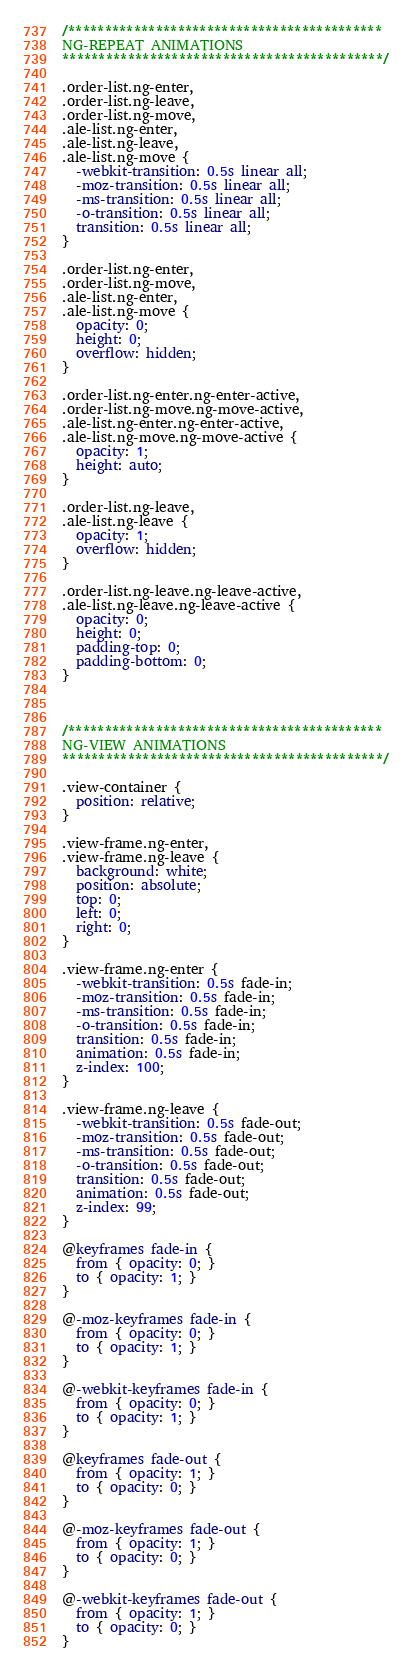Convert code to text. <code><loc_0><loc_0><loc_500><loc_500><_CSS_>/*******************************************
NG-REPEAT ANIMATIONS
********************************************/

.order-list.ng-enter,
.order-list.ng-leave,
.order-list.ng-move,
.ale-list.ng-enter,
.ale-list.ng-leave,
.ale-list.ng-move {
  -webkit-transition: 0.5s linear all;
  -moz-transition: 0.5s linear all;
  -ms-transition: 0.5s linear all;
  -o-transition: 0.5s linear all;
  transition: 0.5s linear all;
}

.order-list.ng-enter,
.order-list.ng-move,
.ale-list.ng-enter,
.ale-list.ng-move {
  opacity: 0;
  height: 0;
  overflow: hidden;
}

.order-list.ng-enter.ng-enter-active,
.order-list.ng-move.ng-move-active,
.ale-list.ng-enter.ng-enter-active,
.ale-list.ng-move.ng-move-active {
  opacity: 1;
  height: auto;
}

.order-list.ng-leave,
.ale-list.ng-leave {
  opacity: 1;
  overflow: hidden;
}

.order-list.ng-leave.ng-leave-active,
.ale-list.ng-leave.ng-leave-active {
  opacity: 0;
  height: 0;
  padding-top: 0;
  padding-bottom: 0;
}



/*******************************************
NG-VIEW ANIMATIONS
********************************************/

.view-container {
  position: relative;
}

.view-frame.ng-enter,
.view-frame.ng-leave {
  background: white;
  position: absolute;
  top: 0;
  left: 0;
  right: 0;
}

.view-frame.ng-enter {
  -webkit-transition: 0.5s fade-in;
  -moz-transition: 0.5s fade-in;
  -ms-transition: 0.5s fade-in;
  -o-transition: 0.5s fade-in;
  transition: 0.5s fade-in;
  animation: 0.5s fade-in;
  z-index: 100;
}

.view-frame.ng-leave {
  -webkit-transition: 0.5s fade-out;
  -moz-transition: 0.5s fade-out;
  -ms-transition: 0.5s fade-out;
  -o-transition: 0.5s fade-out;
  transition: 0.5s fade-out;
  animation: 0.5s fade-out;
  z-index: 99;
}

@keyframes fade-in {
  from { opacity: 0; }
  to { opacity: 1; }
}

@-moz-keyframes fade-in {
  from { opacity: 0; }
  to { opacity: 1; }
}

@-webkit-keyframes fade-in {
  from { opacity: 0; }
  to { opacity: 1; }
}

@keyframes fade-out {
  from { opacity: 1; }
  to { opacity: 0; }
}

@-moz-keyframes fade-out {
  from { opacity: 1; }
  to { opacity: 0; }
}

@-webkit-keyframes fade-out {
  from { opacity: 1; }
  to { opacity: 0; }
}</code> 